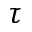<formula> <loc_0><loc_0><loc_500><loc_500>\tau</formula> 